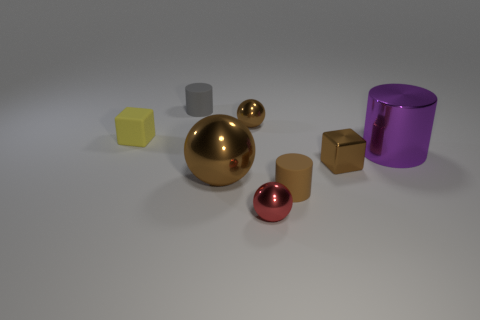Is the color of the shiny cube the same as the large object in front of the big purple shiny cylinder?
Provide a short and direct response. Yes. There is a tiny cylinder that is the same color as the big sphere; what is it made of?
Offer a terse response. Rubber. Is the size of the brown metallic sphere behind the metal block the same as the big purple shiny cylinder?
Ensure brevity in your answer.  No. Does the small shiny object behind the brown shiny cube have the same shape as the large object that is left of the large metallic cylinder?
Your answer should be very brief. Yes. How many other objects are there of the same color as the metallic block?
Keep it short and to the point. 3. What is the material of the tiny sphere that is in front of the tiny brown metal ball in front of the gray cylinder behind the big metal cylinder?
Your answer should be very brief. Metal. The big object right of the small cube on the right side of the gray thing is made of what material?
Keep it short and to the point. Metal. Are there fewer gray matte objects that are to the right of the red ball than green rubber things?
Give a very brief answer. No. There is a large thing behind the big brown metallic object; what is its shape?
Ensure brevity in your answer.  Cylinder. There is a red object; is it the same size as the block that is to the right of the small rubber cube?
Make the answer very short. Yes. 